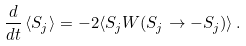<formula> <loc_0><loc_0><loc_500><loc_500>\frac { d } { d t } \, \langle S _ { j } \rangle = - 2 \langle S _ { j } W ( S _ { j } \to - S _ { j } ) \rangle \, .</formula> 